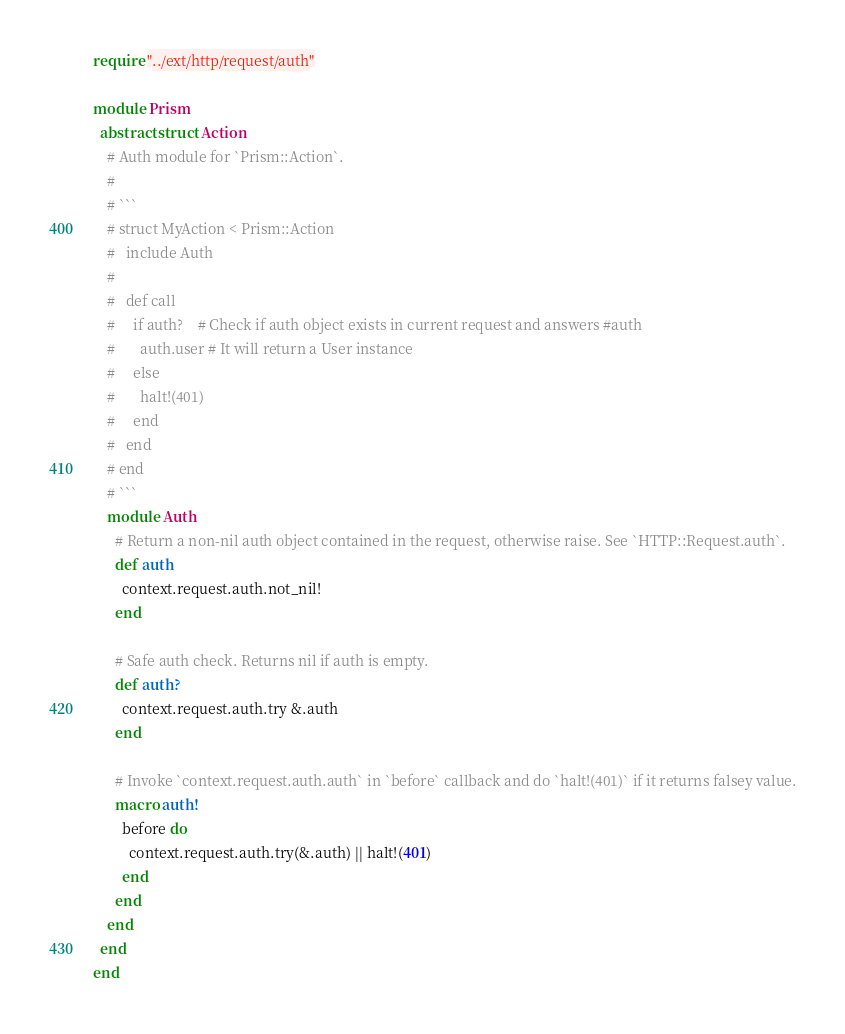Convert code to text. <code><loc_0><loc_0><loc_500><loc_500><_Crystal_>require "../ext/http/request/auth"

module Prism
  abstract struct Action
    # Auth module for `Prism::Action`.
    #
    # ```
    # struct MyAction < Prism::Action
    #   include Auth
    #
    #   def call
    #     if auth?    # Check if auth object exists in current request and answers #auth
    #       auth.user # It will return a User instance
    #     else
    #       halt!(401)
    #     end
    #   end
    # end
    # ```
    module Auth
      # Return a non-nil auth object contained in the request, otherwise raise. See `HTTP::Request.auth`.
      def auth
        context.request.auth.not_nil!
      end

      # Safe auth check. Returns nil if auth is empty.
      def auth?
        context.request.auth.try &.auth
      end

      # Invoke `context.request.auth.auth` in `before` callback and do `halt!(401)` if it returns falsey value.
      macro auth!
        before do
          context.request.auth.try(&.auth) || halt!(401)
        end
      end
    end
  end
end
</code> 